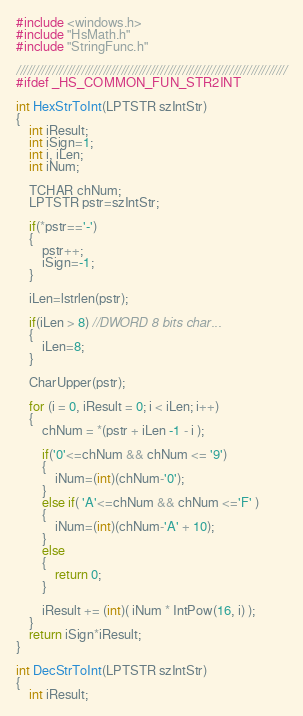Convert code to text. <code><loc_0><loc_0><loc_500><loc_500><_C++_>#include <windows.h>
#include "HsMath.h"
#include "StringFunc.h"

///////////////////////////////////////////////////////////////////////////
#ifdef _HS_COMMON_FUN_STR2INT

int HexStrToInt(LPTSTR szIntStr)
{	
	int iResult;
	int iSign=1;
	int i, iLen;
	int iNum;
	
	TCHAR chNum;
	LPTSTR pstr=szIntStr;
	
	if(*pstr=='-')
	{
		pstr++;
		iSign=-1;
	}
	
	iLen=lstrlen(pstr);
	
	if(iLen > 8) //DWORD 8 bits char...
	{
		iLen=8;
	}
	
	CharUpper(pstr);
	
	for (i = 0, iResult = 0; i < iLen; i++)
	{
		chNum = *(pstr + iLen -1 - i );
		
		if('0'<=chNum && chNum <= '9')
		{
			iNum=(int)(chNum-'0');
		}
		else if( 'A'<=chNum && chNum <='F' )
		{
			iNum=(int)(chNum-'A' + 10);
		}
		else
		{
			return 0;
		}
		
		iResult += (int)( iNum * IntPow(16, i) );
	}
	return iSign*iResult;
}

int DecStrToInt(LPTSTR szIntStr)
{
	int iResult;</code> 